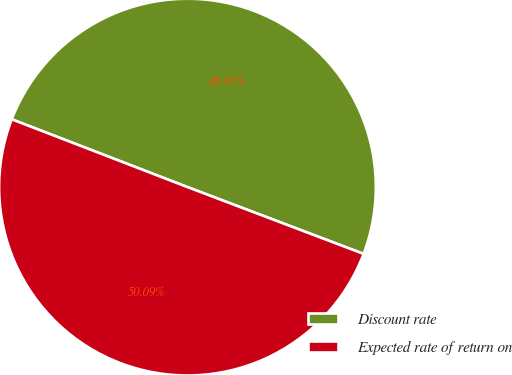Convert chart. <chart><loc_0><loc_0><loc_500><loc_500><pie_chart><fcel>Discount rate<fcel>Expected rate of return on<nl><fcel>49.91%<fcel>50.09%<nl></chart> 